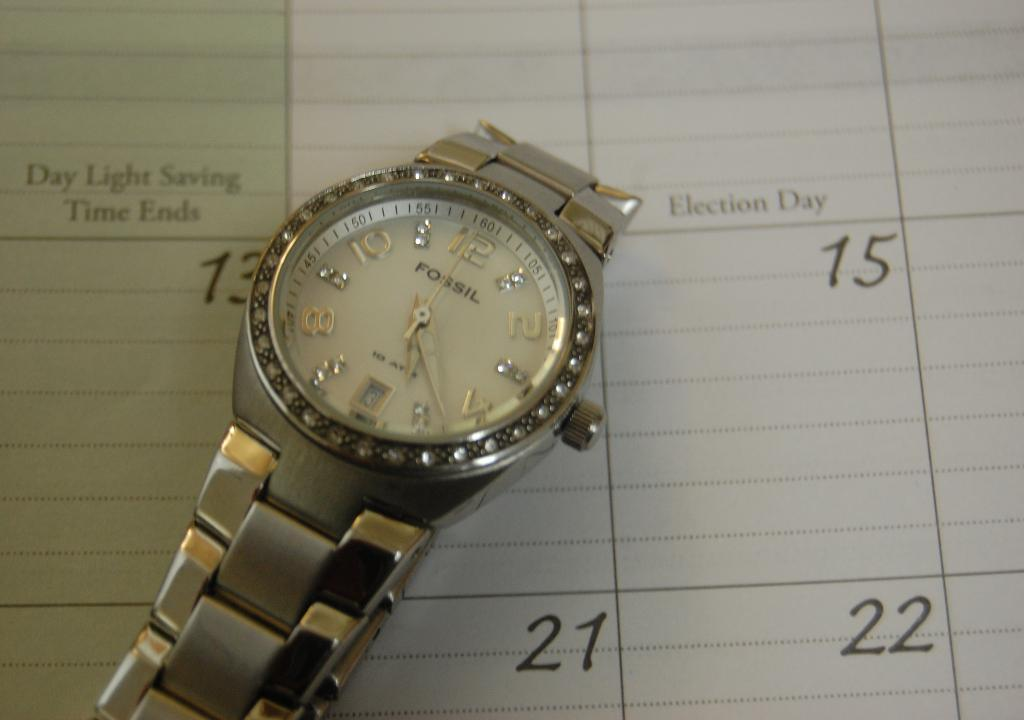Provide a one-sentence caption for the provided image. A silver and gold Fossil watch with crystals surrounding the dial lying on a a calendar. 